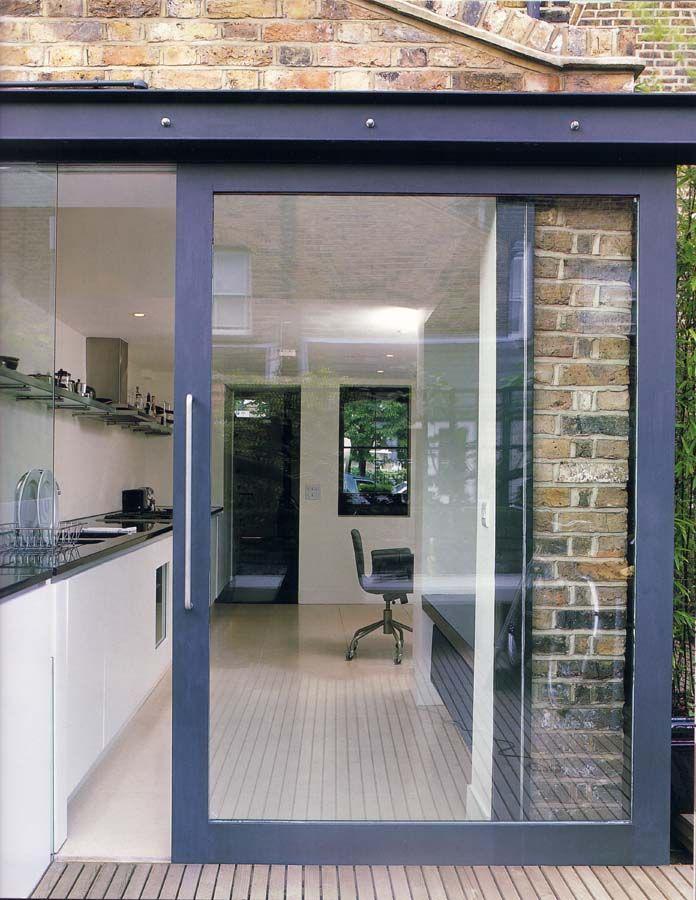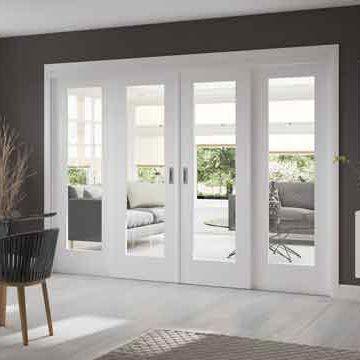The first image is the image on the left, the second image is the image on the right. Given the left and right images, does the statement "There is a potted plant in the image on the left." hold true? Answer yes or no. No. 